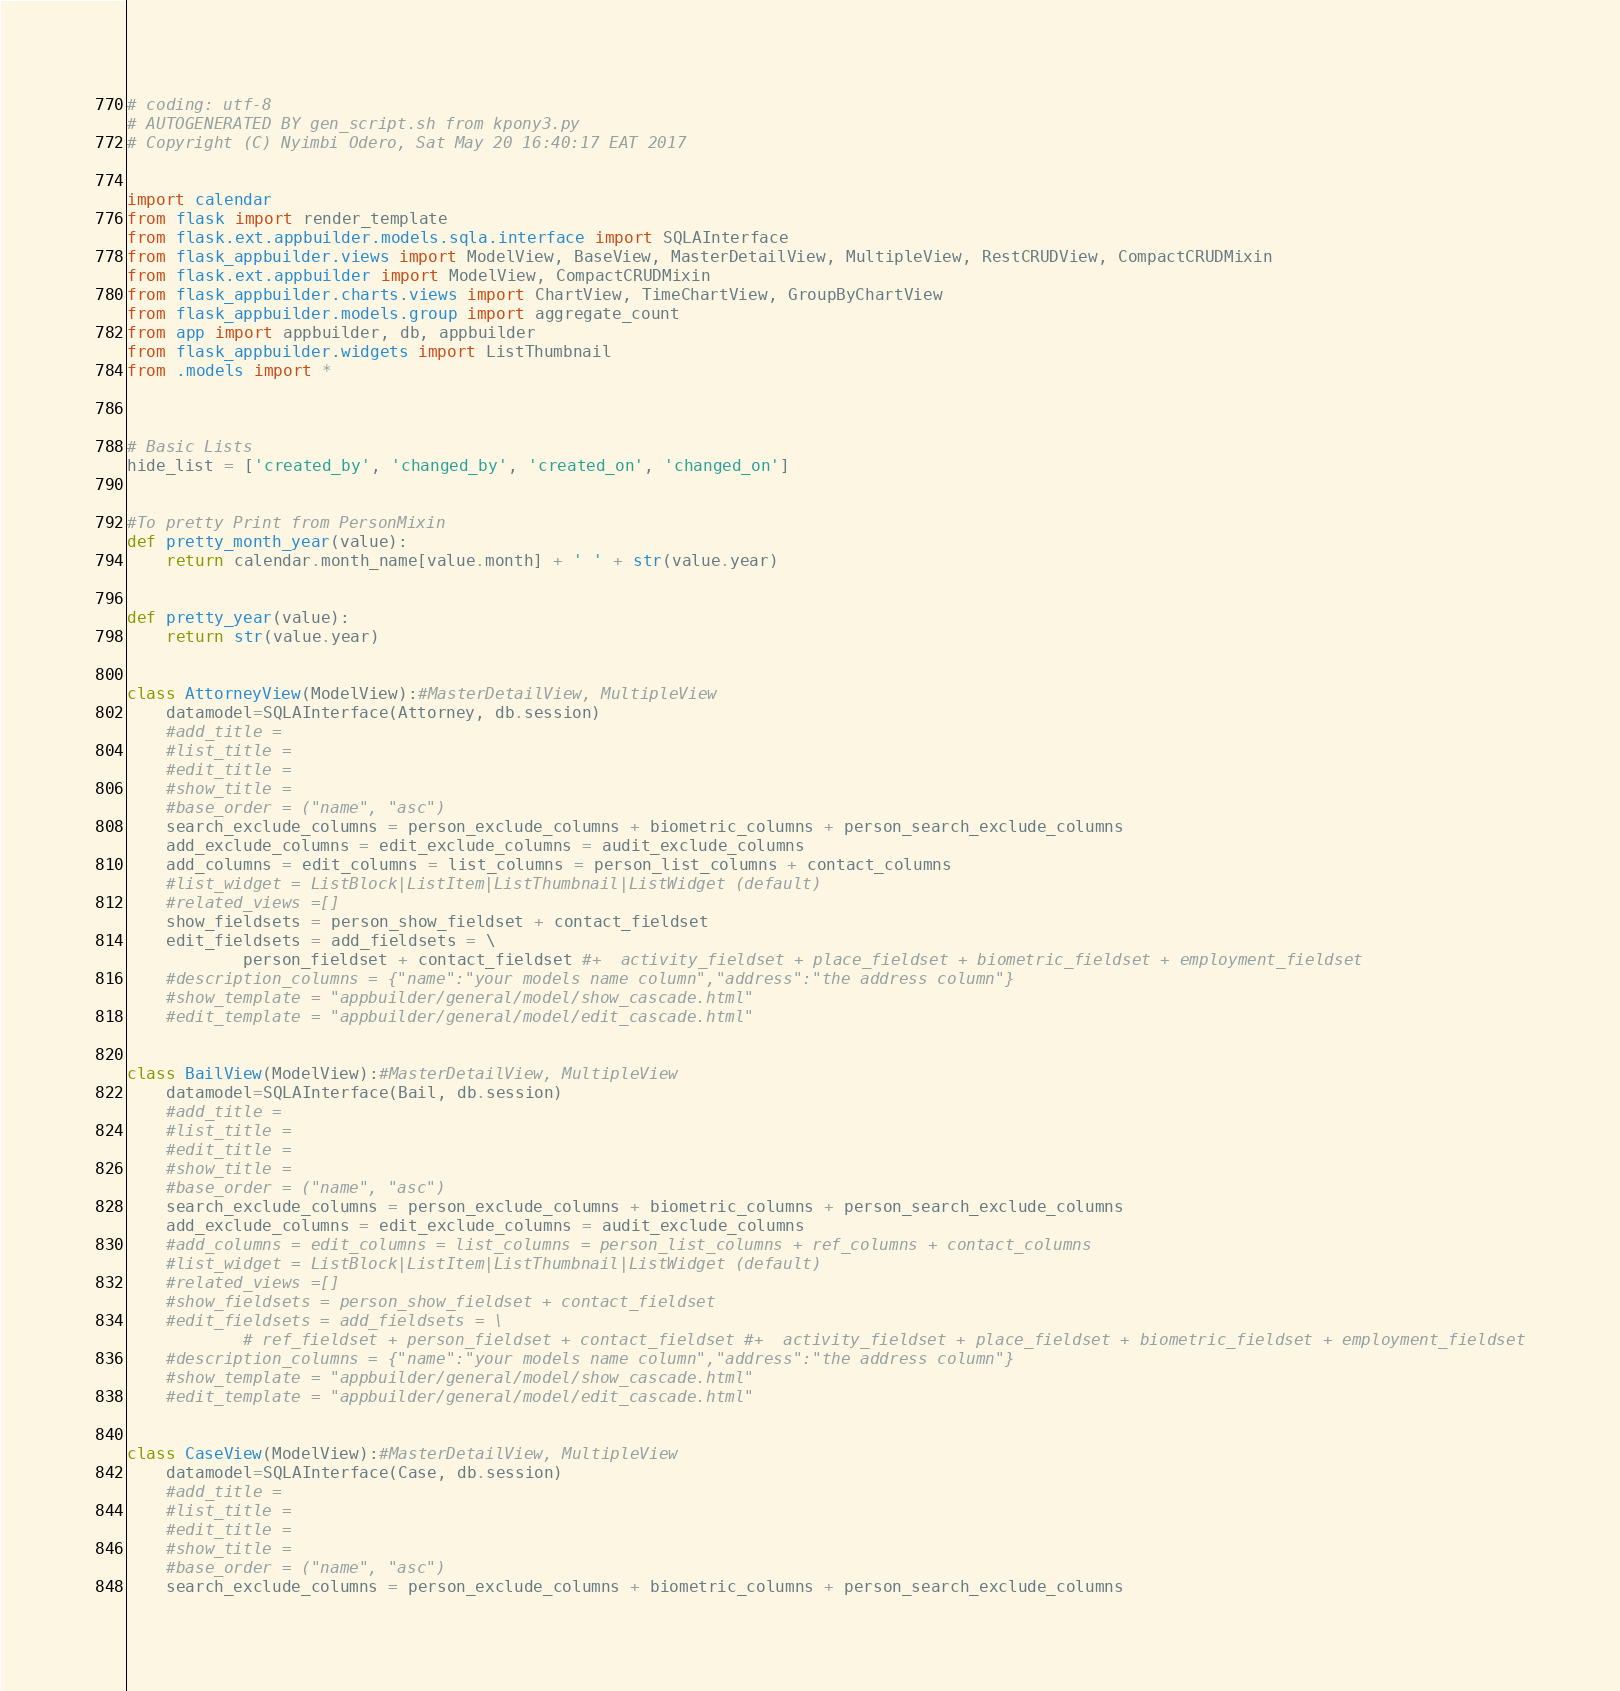<code> <loc_0><loc_0><loc_500><loc_500><_Python_># coding: utf-8
# AUTOGENERATED BY gen_script.sh from kpony3.py
# Copyright (C) Nyimbi Odero, Sat May 20 16:40:17 EAT 2017


import calendar
from flask import render_template
from flask.ext.appbuilder.models.sqla.interface import SQLAInterface
from flask_appbuilder.views import ModelView, BaseView, MasterDetailView, MultipleView, RestCRUDView, CompactCRUDMixin
from flask.ext.appbuilder import ModelView, CompactCRUDMixin
from flask_appbuilder.charts.views import ChartView, TimeChartView, GroupByChartView
from flask_appbuilder.models.group import aggregate_count
from app import appbuilder, db, appbuilder
from flask_appbuilder.widgets import ListThumbnail
from .models import *



# Basic Lists
hide_list = ['created_by', 'changed_by', 'created_on', 'changed_on']


#To pretty Print from PersonMixin
def pretty_month_year(value):
    return calendar.month_name[value.month] + ' ' + str(value.year)
 
 
def pretty_year(value):
    return str(value.year)
 
 
class AttorneyView(ModelView):#MasterDetailView, MultipleView
	datamodel=SQLAInterface(Attorney, db.session)
	#add_title =
	#list_title =
	#edit_title =
	#show_title =
	#base_order = ("name", "asc")
	search_exclude_columns = person_exclude_columns + biometric_columns + person_search_exclude_columns
	add_exclude_columns = edit_exclude_columns = audit_exclude_columns
	add_columns = edit_columns = list_columns = person_list_columns + contact_columns
	#list_widget = ListBlock|ListItem|ListThumbnail|ListWidget (default)
	#related_views =[]
	show_fieldsets = person_show_fieldset + contact_fieldset
	edit_fieldsets = add_fieldsets = \
			person_fieldset + contact_fieldset #+  activity_fieldset + place_fieldset + biometric_fieldset + employment_fieldset
	#description_columns = {"name":"your models name column","address":"the address column"}
	#show_template = "appbuilder/general/model/show_cascade.html"
	#edit_template = "appbuilder/general/model/edit_cascade.html"


class BailView(ModelView):#MasterDetailView, MultipleView
	datamodel=SQLAInterface(Bail, db.session)
	#add_title =
	#list_title =
	#edit_title =
	#show_title =
	#base_order = ("name", "asc")
	search_exclude_columns = person_exclude_columns + biometric_columns + person_search_exclude_columns
	add_exclude_columns = edit_exclude_columns = audit_exclude_columns
	#add_columns = edit_columns = list_columns = person_list_columns + ref_columns + contact_columns
	#list_widget = ListBlock|ListItem|ListThumbnail|ListWidget (default)
	#related_views =[]
	#show_fieldsets = person_show_fieldset + contact_fieldset
	#edit_fieldsets = add_fieldsets = \
			# ref_fieldset + person_fieldset + contact_fieldset #+  activity_fieldset + place_fieldset + biometric_fieldset + employment_fieldset
	#description_columns = {"name":"your models name column","address":"the address column"}
	#show_template = "appbuilder/general/model/show_cascade.html"
	#edit_template = "appbuilder/general/model/edit_cascade.html"


class CaseView(ModelView):#MasterDetailView, MultipleView
	datamodel=SQLAInterface(Case, db.session)
	#add_title =
	#list_title =
	#edit_title =
	#show_title =
	#base_order = ("name", "asc")
	search_exclude_columns = person_exclude_columns + biometric_columns + person_search_exclude_columns</code> 